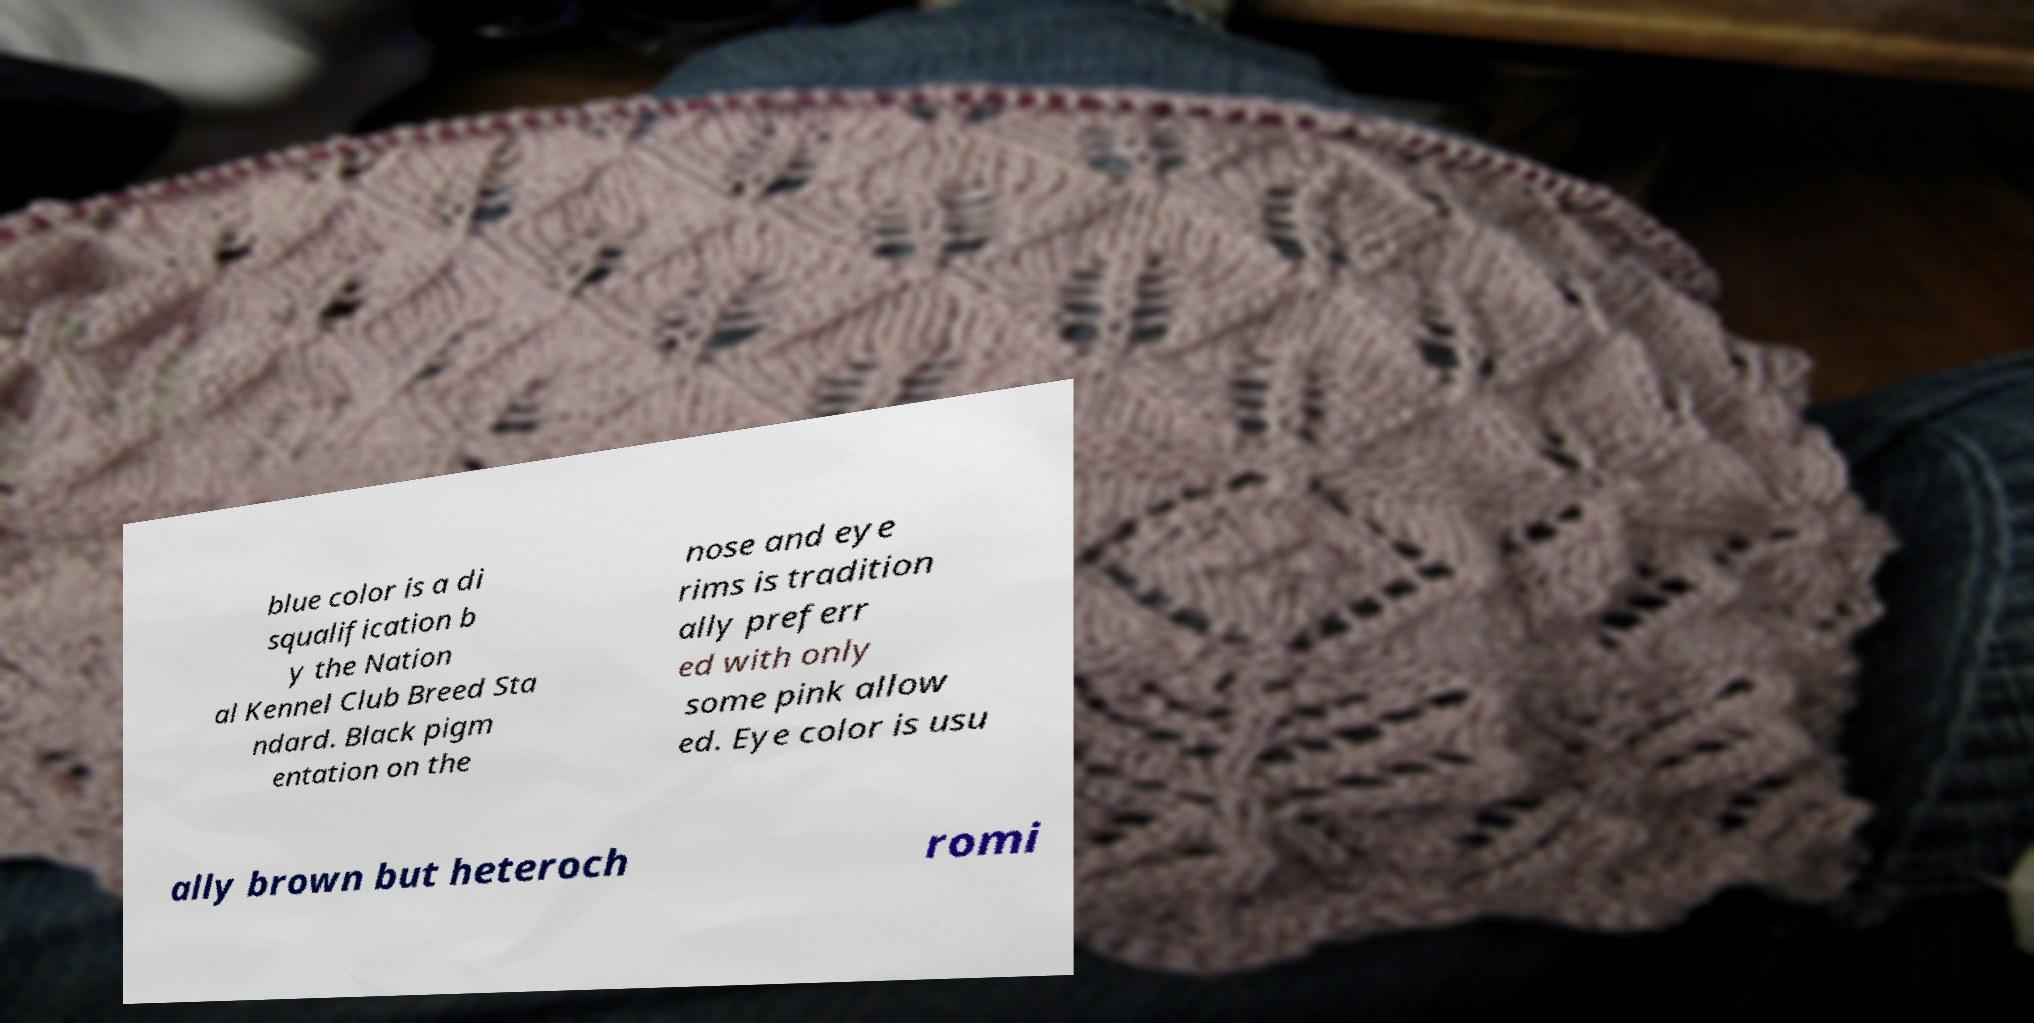There's text embedded in this image that I need extracted. Can you transcribe it verbatim? blue color is a di squalification b y the Nation al Kennel Club Breed Sta ndard. Black pigm entation on the nose and eye rims is tradition ally preferr ed with only some pink allow ed. Eye color is usu ally brown but heteroch romi 